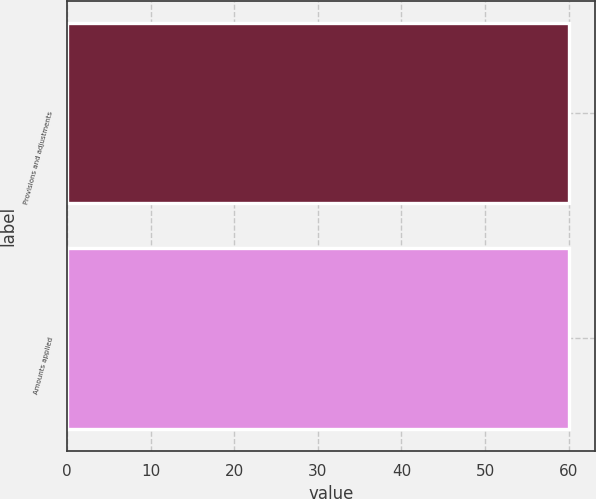<chart> <loc_0><loc_0><loc_500><loc_500><bar_chart><fcel>Provisions and adjustments<fcel>Amounts applied<nl><fcel>60<fcel>60.1<nl></chart> 